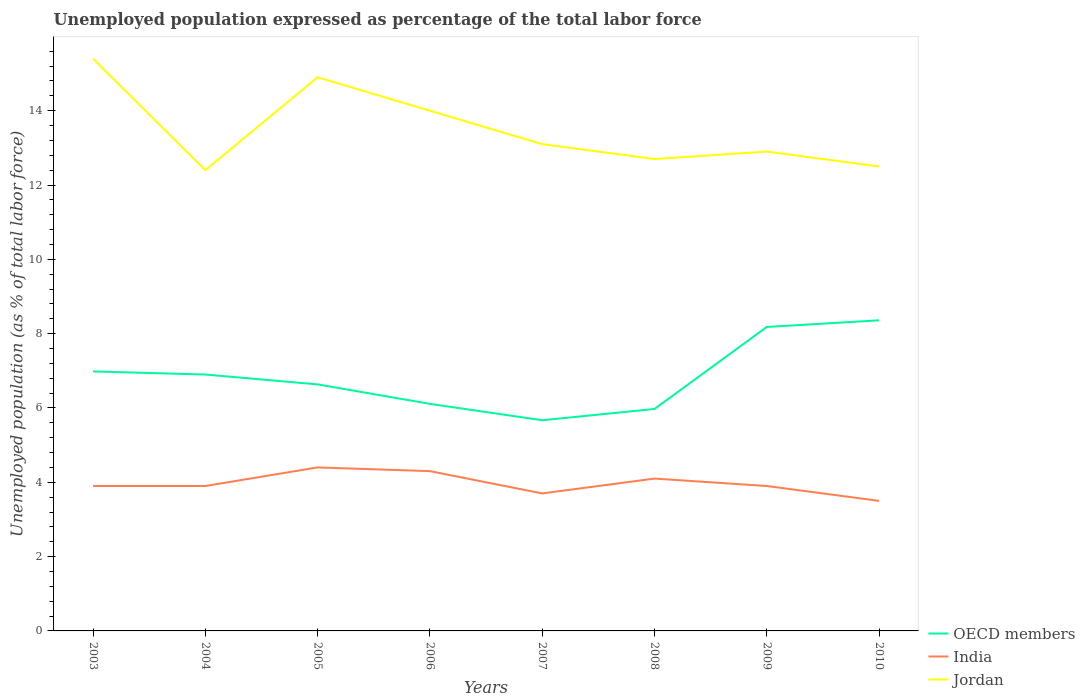How many different coloured lines are there?
Provide a short and direct response. 3. Across all years, what is the maximum unemployment in in OECD members?
Provide a succinct answer. 5.67. In which year was the unemployment in in India maximum?
Offer a terse response. 2010. What is the total unemployment in in Jordan in the graph?
Make the answer very short. 1.4. What is the difference between the highest and the second highest unemployment in in India?
Your response must be concise. 0.9. How many lines are there?
Your answer should be compact. 3. How many years are there in the graph?
Offer a very short reply. 8. Does the graph contain any zero values?
Give a very brief answer. No. Where does the legend appear in the graph?
Provide a succinct answer. Bottom right. How are the legend labels stacked?
Your answer should be compact. Vertical. What is the title of the graph?
Offer a terse response. Unemployed population expressed as percentage of the total labor force. What is the label or title of the X-axis?
Provide a short and direct response. Years. What is the label or title of the Y-axis?
Give a very brief answer. Unemployed population (as % of total labor force). What is the Unemployed population (as % of total labor force) of OECD members in 2003?
Keep it short and to the point. 6.98. What is the Unemployed population (as % of total labor force) of India in 2003?
Ensure brevity in your answer.  3.9. What is the Unemployed population (as % of total labor force) of Jordan in 2003?
Your answer should be compact. 15.4. What is the Unemployed population (as % of total labor force) of OECD members in 2004?
Provide a short and direct response. 6.9. What is the Unemployed population (as % of total labor force) of India in 2004?
Your response must be concise. 3.9. What is the Unemployed population (as % of total labor force) of Jordan in 2004?
Offer a very short reply. 12.4. What is the Unemployed population (as % of total labor force) of OECD members in 2005?
Keep it short and to the point. 6.63. What is the Unemployed population (as % of total labor force) in India in 2005?
Keep it short and to the point. 4.4. What is the Unemployed population (as % of total labor force) in Jordan in 2005?
Provide a succinct answer. 14.9. What is the Unemployed population (as % of total labor force) in OECD members in 2006?
Keep it short and to the point. 6.11. What is the Unemployed population (as % of total labor force) of India in 2006?
Keep it short and to the point. 4.3. What is the Unemployed population (as % of total labor force) of OECD members in 2007?
Offer a terse response. 5.67. What is the Unemployed population (as % of total labor force) in India in 2007?
Keep it short and to the point. 3.7. What is the Unemployed population (as % of total labor force) in Jordan in 2007?
Provide a short and direct response. 13.1. What is the Unemployed population (as % of total labor force) of OECD members in 2008?
Keep it short and to the point. 5.97. What is the Unemployed population (as % of total labor force) in India in 2008?
Ensure brevity in your answer.  4.1. What is the Unemployed population (as % of total labor force) of Jordan in 2008?
Make the answer very short. 12.7. What is the Unemployed population (as % of total labor force) in OECD members in 2009?
Offer a very short reply. 8.18. What is the Unemployed population (as % of total labor force) of India in 2009?
Your answer should be very brief. 3.9. What is the Unemployed population (as % of total labor force) in Jordan in 2009?
Your answer should be compact. 12.9. What is the Unemployed population (as % of total labor force) of OECD members in 2010?
Ensure brevity in your answer.  8.36. What is the Unemployed population (as % of total labor force) in Jordan in 2010?
Make the answer very short. 12.5. Across all years, what is the maximum Unemployed population (as % of total labor force) in OECD members?
Offer a terse response. 8.36. Across all years, what is the maximum Unemployed population (as % of total labor force) of India?
Provide a short and direct response. 4.4. Across all years, what is the maximum Unemployed population (as % of total labor force) in Jordan?
Keep it short and to the point. 15.4. Across all years, what is the minimum Unemployed population (as % of total labor force) in OECD members?
Offer a terse response. 5.67. Across all years, what is the minimum Unemployed population (as % of total labor force) in Jordan?
Keep it short and to the point. 12.4. What is the total Unemployed population (as % of total labor force) in OECD members in the graph?
Give a very brief answer. 54.81. What is the total Unemployed population (as % of total labor force) of India in the graph?
Ensure brevity in your answer.  31.7. What is the total Unemployed population (as % of total labor force) of Jordan in the graph?
Provide a short and direct response. 107.9. What is the difference between the Unemployed population (as % of total labor force) in OECD members in 2003 and that in 2004?
Your answer should be very brief. 0.08. What is the difference between the Unemployed population (as % of total labor force) in India in 2003 and that in 2004?
Your response must be concise. 0. What is the difference between the Unemployed population (as % of total labor force) of OECD members in 2003 and that in 2005?
Make the answer very short. 0.35. What is the difference between the Unemployed population (as % of total labor force) of India in 2003 and that in 2005?
Offer a very short reply. -0.5. What is the difference between the Unemployed population (as % of total labor force) of Jordan in 2003 and that in 2005?
Provide a short and direct response. 0.5. What is the difference between the Unemployed population (as % of total labor force) of OECD members in 2003 and that in 2006?
Keep it short and to the point. 0.87. What is the difference between the Unemployed population (as % of total labor force) of OECD members in 2003 and that in 2007?
Keep it short and to the point. 1.31. What is the difference between the Unemployed population (as % of total labor force) in India in 2003 and that in 2007?
Your answer should be very brief. 0.2. What is the difference between the Unemployed population (as % of total labor force) of Jordan in 2003 and that in 2007?
Make the answer very short. 2.3. What is the difference between the Unemployed population (as % of total labor force) in OECD members in 2003 and that in 2008?
Offer a terse response. 1.01. What is the difference between the Unemployed population (as % of total labor force) of India in 2003 and that in 2008?
Provide a succinct answer. -0.2. What is the difference between the Unemployed population (as % of total labor force) in OECD members in 2003 and that in 2009?
Make the answer very short. -1.2. What is the difference between the Unemployed population (as % of total labor force) of OECD members in 2003 and that in 2010?
Ensure brevity in your answer.  -1.38. What is the difference between the Unemployed population (as % of total labor force) of India in 2003 and that in 2010?
Provide a succinct answer. 0.4. What is the difference between the Unemployed population (as % of total labor force) in Jordan in 2003 and that in 2010?
Give a very brief answer. 2.9. What is the difference between the Unemployed population (as % of total labor force) of OECD members in 2004 and that in 2005?
Provide a succinct answer. 0.27. What is the difference between the Unemployed population (as % of total labor force) of Jordan in 2004 and that in 2005?
Provide a succinct answer. -2.5. What is the difference between the Unemployed population (as % of total labor force) of OECD members in 2004 and that in 2006?
Ensure brevity in your answer.  0.79. What is the difference between the Unemployed population (as % of total labor force) in India in 2004 and that in 2006?
Your answer should be very brief. -0.4. What is the difference between the Unemployed population (as % of total labor force) of OECD members in 2004 and that in 2007?
Ensure brevity in your answer.  1.23. What is the difference between the Unemployed population (as % of total labor force) of India in 2004 and that in 2007?
Provide a short and direct response. 0.2. What is the difference between the Unemployed population (as % of total labor force) in OECD members in 2004 and that in 2008?
Offer a terse response. 0.93. What is the difference between the Unemployed population (as % of total labor force) of OECD members in 2004 and that in 2009?
Keep it short and to the point. -1.28. What is the difference between the Unemployed population (as % of total labor force) of India in 2004 and that in 2009?
Ensure brevity in your answer.  0. What is the difference between the Unemployed population (as % of total labor force) of Jordan in 2004 and that in 2009?
Keep it short and to the point. -0.5. What is the difference between the Unemployed population (as % of total labor force) of OECD members in 2004 and that in 2010?
Your answer should be very brief. -1.46. What is the difference between the Unemployed population (as % of total labor force) in India in 2004 and that in 2010?
Your answer should be very brief. 0.4. What is the difference between the Unemployed population (as % of total labor force) in OECD members in 2005 and that in 2006?
Keep it short and to the point. 0.52. What is the difference between the Unemployed population (as % of total labor force) of India in 2005 and that in 2006?
Ensure brevity in your answer.  0.1. What is the difference between the Unemployed population (as % of total labor force) in OECD members in 2005 and that in 2007?
Provide a short and direct response. 0.96. What is the difference between the Unemployed population (as % of total labor force) of India in 2005 and that in 2007?
Ensure brevity in your answer.  0.7. What is the difference between the Unemployed population (as % of total labor force) in Jordan in 2005 and that in 2007?
Make the answer very short. 1.8. What is the difference between the Unemployed population (as % of total labor force) of OECD members in 2005 and that in 2008?
Your answer should be compact. 0.66. What is the difference between the Unemployed population (as % of total labor force) of Jordan in 2005 and that in 2008?
Provide a short and direct response. 2.2. What is the difference between the Unemployed population (as % of total labor force) in OECD members in 2005 and that in 2009?
Offer a very short reply. -1.55. What is the difference between the Unemployed population (as % of total labor force) in OECD members in 2005 and that in 2010?
Keep it short and to the point. -1.72. What is the difference between the Unemployed population (as % of total labor force) of Jordan in 2005 and that in 2010?
Provide a succinct answer. 2.4. What is the difference between the Unemployed population (as % of total labor force) of OECD members in 2006 and that in 2007?
Your answer should be compact. 0.44. What is the difference between the Unemployed population (as % of total labor force) in Jordan in 2006 and that in 2007?
Provide a short and direct response. 0.9. What is the difference between the Unemployed population (as % of total labor force) in OECD members in 2006 and that in 2008?
Your response must be concise. 0.14. What is the difference between the Unemployed population (as % of total labor force) in India in 2006 and that in 2008?
Provide a succinct answer. 0.2. What is the difference between the Unemployed population (as % of total labor force) of OECD members in 2006 and that in 2009?
Give a very brief answer. -2.07. What is the difference between the Unemployed population (as % of total labor force) in India in 2006 and that in 2009?
Offer a very short reply. 0.4. What is the difference between the Unemployed population (as % of total labor force) of Jordan in 2006 and that in 2009?
Offer a terse response. 1.1. What is the difference between the Unemployed population (as % of total labor force) of OECD members in 2006 and that in 2010?
Provide a short and direct response. -2.25. What is the difference between the Unemployed population (as % of total labor force) in India in 2006 and that in 2010?
Offer a terse response. 0.8. What is the difference between the Unemployed population (as % of total labor force) in Jordan in 2006 and that in 2010?
Your answer should be very brief. 1.5. What is the difference between the Unemployed population (as % of total labor force) of OECD members in 2007 and that in 2008?
Your answer should be compact. -0.3. What is the difference between the Unemployed population (as % of total labor force) of India in 2007 and that in 2008?
Offer a terse response. -0.4. What is the difference between the Unemployed population (as % of total labor force) in OECD members in 2007 and that in 2009?
Keep it short and to the point. -2.51. What is the difference between the Unemployed population (as % of total labor force) of India in 2007 and that in 2009?
Your answer should be very brief. -0.2. What is the difference between the Unemployed population (as % of total labor force) in OECD members in 2007 and that in 2010?
Provide a short and direct response. -2.69. What is the difference between the Unemployed population (as % of total labor force) in India in 2007 and that in 2010?
Your response must be concise. 0.2. What is the difference between the Unemployed population (as % of total labor force) of Jordan in 2007 and that in 2010?
Your answer should be compact. 0.6. What is the difference between the Unemployed population (as % of total labor force) in OECD members in 2008 and that in 2009?
Provide a succinct answer. -2.21. What is the difference between the Unemployed population (as % of total labor force) of India in 2008 and that in 2009?
Give a very brief answer. 0.2. What is the difference between the Unemployed population (as % of total labor force) in Jordan in 2008 and that in 2009?
Your response must be concise. -0.2. What is the difference between the Unemployed population (as % of total labor force) in OECD members in 2008 and that in 2010?
Keep it short and to the point. -2.39. What is the difference between the Unemployed population (as % of total labor force) of India in 2008 and that in 2010?
Make the answer very short. 0.6. What is the difference between the Unemployed population (as % of total labor force) in OECD members in 2009 and that in 2010?
Provide a short and direct response. -0.18. What is the difference between the Unemployed population (as % of total labor force) of India in 2009 and that in 2010?
Make the answer very short. 0.4. What is the difference between the Unemployed population (as % of total labor force) in Jordan in 2009 and that in 2010?
Make the answer very short. 0.4. What is the difference between the Unemployed population (as % of total labor force) in OECD members in 2003 and the Unemployed population (as % of total labor force) in India in 2004?
Your answer should be very brief. 3.08. What is the difference between the Unemployed population (as % of total labor force) in OECD members in 2003 and the Unemployed population (as % of total labor force) in Jordan in 2004?
Provide a short and direct response. -5.42. What is the difference between the Unemployed population (as % of total labor force) in OECD members in 2003 and the Unemployed population (as % of total labor force) in India in 2005?
Keep it short and to the point. 2.58. What is the difference between the Unemployed population (as % of total labor force) in OECD members in 2003 and the Unemployed population (as % of total labor force) in Jordan in 2005?
Your answer should be very brief. -7.92. What is the difference between the Unemployed population (as % of total labor force) in OECD members in 2003 and the Unemployed population (as % of total labor force) in India in 2006?
Make the answer very short. 2.68. What is the difference between the Unemployed population (as % of total labor force) in OECD members in 2003 and the Unemployed population (as % of total labor force) in Jordan in 2006?
Make the answer very short. -7.02. What is the difference between the Unemployed population (as % of total labor force) in India in 2003 and the Unemployed population (as % of total labor force) in Jordan in 2006?
Offer a very short reply. -10.1. What is the difference between the Unemployed population (as % of total labor force) of OECD members in 2003 and the Unemployed population (as % of total labor force) of India in 2007?
Your answer should be compact. 3.28. What is the difference between the Unemployed population (as % of total labor force) in OECD members in 2003 and the Unemployed population (as % of total labor force) in Jordan in 2007?
Ensure brevity in your answer.  -6.12. What is the difference between the Unemployed population (as % of total labor force) of India in 2003 and the Unemployed population (as % of total labor force) of Jordan in 2007?
Keep it short and to the point. -9.2. What is the difference between the Unemployed population (as % of total labor force) of OECD members in 2003 and the Unemployed population (as % of total labor force) of India in 2008?
Make the answer very short. 2.88. What is the difference between the Unemployed population (as % of total labor force) of OECD members in 2003 and the Unemployed population (as % of total labor force) of Jordan in 2008?
Provide a short and direct response. -5.72. What is the difference between the Unemployed population (as % of total labor force) in India in 2003 and the Unemployed population (as % of total labor force) in Jordan in 2008?
Your answer should be compact. -8.8. What is the difference between the Unemployed population (as % of total labor force) in OECD members in 2003 and the Unemployed population (as % of total labor force) in India in 2009?
Ensure brevity in your answer.  3.08. What is the difference between the Unemployed population (as % of total labor force) of OECD members in 2003 and the Unemployed population (as % of total labor force) of Jordan in 2009?
Keep it short and to the point. -5.92. What is the difference between the Unemployed population (as % of total labor force) of India in 2003 and the Unemployed population (as % of total labor force) of Jordan in 2009?
Give a very brief answer. -9. What is the difference between the Unemployed population (as % of total labor force) of OECD members in 2003 and the Unemployed population (as % of total labor force) of India in 2010?
Your answer should be compact. 3.48. What is the difference between the Unemployed population (as % of total labor force) of OECD members in 2003 and the Unemployed population (as % of total labor force) of Jordan in 2010?
Make the answer very short. -5.52. What is the difference between the Unemployed population (as % of total labor force) in OECD members in 2004 and the Unemployed population (as % of total labor force) in India in 2005?
Offer a very short reply. 2.5. What is the difference between the Unemployed population (as % of total labor force) in OECD members in 2004 and the Unemployed population (as % of total labor force) in Jordan in 2005?
Give a very brief answer. -8. What is the difference between the Unemployed population (as % of total labor force) of OECD members in 2004 and the Unemployed population (as % of total labor force) of India in 2006?
Ensure brevity in your answer.  2.6. What is the difference between the Unemployed population (as % of total labor force) of OECD members in 2004 and the Unemployed population (as % of total labor force) of Jordan in 2006?
Provide a succinct answer. -7.1. What is the difference between the Unemployed population (as % of total labor force) of India in 2004 and the Unemployed population (as % of total labor force) of Jordan in 2006?
Give a very brief answer. -10.1. What is the difference between the Unemployed population (as % of total labor force) in OECD members in 2004 and the Unemployed population (as % of total labor force) in India in 2007?
Offer a very short reply. 3.2. What is the difference between the Unemployed population (as % of total labor force) of OECD members in 2004 and the Unemployed population (as % of total labor force) of Jordan in 2007?
Offer a terse response. -6.2. What is the difference between the Unemployed population (as % of total labor force) of OECD members in 2004 and the Unemployed population (as % of total labor force) of India in 2008?
Provide a short and direct response. 2.8. What is the difference between the Unemployed population (as % of total labor force) of OECD members in 2004 and the Unemployed population (as % of total labor force) of Jordan in 2008?
Provide a short and direct response. -5.8. What is the difference between the Unemployed population (as % of total labor force) of OECD members in 2004 and the Unemployed population (as % of total labor force) of India in 2009?
Offer a very short reply. 3. What is the difference between the Unemployed population (as % of total labor force) in OECD members in 2004 and the Unemployed population (as % of total labor force) in Jordan in 2009?
Provide a succinct answer. -6. What is the difference between the Unemployed population (as % of total labor force) in OECD members in 2004 and the Unemployed population (as % of total labor force) in India in 2010?
Make the answer very short. 3.4. What is the difference between the Unemployed population (as % of total labor force) of OECD members in 2004 and the Unemployed population (as % of total labor force) of Jordan in 2010?
Offer a terse response. -5.6. What is the difference between the Unemployed population (as % of total labor force) in India in 2004 and the Unemployed population (as % of total labor force) in Jordan in 2010?
Give a very brief answer. -8.6. What is the difference between the Unemployed population (as % of total labor force) of OECD members in 2005 and the Unemployed population (as % of total labor force) of India in 2006?
Your answer should be compact. 2.33. What is the difference between the Unemployed population (as % of total labor force) in OECD members in 2005 and the Unemployed population (as % of total labor force) in Jordan in 2006?
Give a very brief answer. -7.37. What is the difference between the Unemployed population (as % of total labor force) in OECD members in 2005 and the Unemployed population (as % of total labor force) in India in 2007?
Keep it short and to the point. 2.93. What is the difference between the Unemployed population (as % of total labor force) in OECD members in 2005 and the Unemployed population (as % of total labor force) in Jordan in 2007?
Your answer should be very brief. -6.47. What is the difference between the Unemployed population (as % of total labor force) in OECD members in 2005 and the Unemployed population (as % of total labor force) in India in 2008?
Your answer should be very brief. 2.53. What is the difference between the Unemployed population (as % of total labor force) in OECD members in 2005 and the Unemployed population (as % of total labor force) in Jordan in 2008?
Ensure brevity in your answer.  -6.07. What is the difference between the Unemployed population (as % of total labor force) in India in 2005 and the Unemployed population (as % of total labor force) in Jordan in 2008?
Provide a short and direct response. -8.3. What is the difference between the Unemployed population (as % of total labor force) of OECD members in 2005 and the Unemployed population (as % of total labor force) of India in 2009?
Give a very brief answer. 2.73. What is the difference between the Unemployed population (as % of total labor force) in OECD members in 2005 and the Unemployed population (as % of total labor force) in Jordan in 2009?
Offer a very short reply. -6.27. What is the difference between the Unemployed population (as % of total labor force) in OECD members in 2005 and the Unemployed population (as % of total labor force) in India in 2010?
Your answer should be very brief. 3.13. What is the difference between the Unemployed population (as % of total labor force) of OECD members in 2005 and the Unemployed population (as % of total labor force) of Jordan in 2010?
Keep it short and to the point. -5.87. What is the difference between the Unemployed population (as % of total labor force) in India in 2005 and the Unemployed population (as % of total labor force) in Jordan in 2010?
Your answer should be very brief. -8.1. What is the difference between the Unemployed population (as % of total labor force) of OECD members in 2006 and the Unemployed population (as % of total labor force) of India in 2007?
Offer a terse response. 2.41. What is the difference between the Unemployed population (as % of total labor force) in OECD members in 2006 and the Unemployed population (as % of total labor force) in Jordan in 2007?
Your answer should be very brief. -6.99. What is the difference between the Unemployed population (as % of total labor force) in India in 2006 and the Unemployed population (as % of total labor force) in Jordan in 2007?
Keep it short and to the point. -8.8. What is the difference between the Unemployed population (as % of total labor force) of OECD members in 2006 and the Unemployed population (as % of total labor force) of India in 2008?
Your answer should be very brief. 2.01. What is the difference between the Unemployed population (as % of total labor force) of OECD members in 2006 and the Unemployed population (as % of total labor force) of Jordan in 2008?
Keep it short and to the point. -6.59. What is the difference between the Unemployed population (as % of total labor force) of OECD members in 2006 and the Unemployed population (as % of total labor force) of India in 2009?
Offer a very short reply. 2.21. What is the difference between the Unemployed population (as % of total labor force) of OECD members in 2006 and the Unemployed population (as % of total labor force) of Jordan in 2009?
Offer a terse response. -6.79. What is the difference between the Unemployed population (as % of total labor force) in India in 2006 and the Unemployed population (as % of total labor force) in Jordan in 2009?
Ensure brevity in your answer.  -8.6. What is the difference between the Unemployed population (as % of total labor force) in OECD members in 2006 and the Unemployed population (as % of total labor force) in India in 2010?
Ensure brevity in your answer.  2.61. What is the difference between the Unemployed population (as % of total labor force) in OECD members in 2006 and the Unemployed population (as % of total labor force) in Jordan in 2010?
Keep it short and to the point. -6.39. What is the difference between the Unemployed population (as % of total labor force) in India in 2006 and the Unemployed population (as % of total labor force) in Jordan in 2010?
Your answer should be compact. -8.2. What is the difference between the Unemployed population (as % of total labor force) of OECD members in 2007 and the Unemployed population (as % of total labor force) of India in 2008?
Your answer should be very brief. 1.57. What is the difference between the Unemployed population (as % of total labor force) of OECD members in 2007 and the Unemployed population (as % of total labor force) of Jordan in 2008?
Ensure brevity in your answer.  -7.03. What is the difference between the Unemployed population (as % of total labor force) of India in 2007 and the Unemployed population (as % of total labor force) of Jordan in 2008?
Ensure brevity in your answer.  -9. What is the difference between the Unemployed population (as % of total labor force) in OECD members in 2007 and the Unemployed population (as % of total labor force) in India in 2009?
Give a very brief answer. 1.77. What is the difference between the Unemployed population (as % of total labor force) in OECD members in 2007 and the Unemployed population (as % of total labor force) in Jordan in 2009?
Keep it short and to the point. -7.23. What is the difference between the Unemployed population (as % of total labor force) in OECD members in 2007 and the Unemployed population (as % of total labor force) in India in 2010?
Provide a succinct answer. 2.17. What is the difference between the Unemployed population (as % of total labor force) of OECD members in 2007 and the Unemployed population (as % of total labor force) of Jordan in 2010?
Offer a very short reply. -6.83. What is the difference between the Unemployed population (as % of total labor force) of OECD members in 2008 and the Unemployed population (as % of total labor force) of India in 2009?
Give a very brief answer. 2.07. What is the difference between the Unemployed population (as % of total labor force) in OECD members in 2008 and the Unemployed population (as % of total labor force) in Jordan in 2009?
Give a very brief answer. -6.93. What is the difference between the Unemployed population (as % of total labor force) of OECD members in 2008 and the Unemployed population (as % of total labor force) of India in 2010?
Make the answer very short. 2.47. What is the difference between the Unemployed population (as % of total labor force) of OECD members in 2008 and the Unemployed population (as % of total labor force) of Jordan in 2010?
Your answer should be compact. -6.53. What is the difference between the Unemployed population (as % of total labor force) of India in 2008 and the Unemployed population (as % of total labor force) of Jordan in 2010?
Your answer should be very brief. -8.4. What is the difference between the Unemployed population (as % of total labor force) of OECD members in 2009 and the Unemployed population (as % of total labor force) of India in 2010?
Your response must be concise. 4.68. What is the difference between the Unemployed population (as % of total labor force) in OECD members in 2009 and the Unemployed population (as % of total labor force) in Jordan in 2010?
Your answer should be compact. -4.32. What is the average Unemployed population (as % of total labor force) of OECD members per year?
Make the answer very short. 6.85. What is the average Unemployed population (as % of total labor force) in India per year?
Your answer should be very brief. 3.96. What is the average Unemployed population (as % of total labor force) in Jordan per year?
Make the answer very short. 13.49. In the year 2003, what is the difference between the Unemployed population (as % of total labor force) in OECD members and Unemployed population (as % of total labor force) in India?
Keep it short and to the point. 3.08. In the year 2003, what is the difference between the Unemployed population (as % of total labor force) of OECD members and Unemployed population (as % of total labor force) of Jordan?
Provide a short and direct response. -8.42. In the year 2004, what is the difference between the Unemployed population (as % of total labor force) in OECD members and Unemployed population (as % of total labor force) in India?
Provide a succinct answer. 3. In the year 2004, what is the difference between the Unemployed population (as % of total labor force) of OECD members and Unemployed population (as % of total labor force) of Jordan?
Offer a terse response. -5.5. In the year 2005, what is the difference between the Unemployed population (as % of total labor force) of OECD members and Unemployed population (as % of total labor force) of India?
Your answer should be very brief. 2.23. In the year 2005, what is the difference between the Unemployed population (as % of total labor force) of OECD members and Unemployed population (as % of total labor force) of Jordan?
Make the answer very short. -8.27. In the year 2006, what is the difference between the Unemployed population (as % of total labor force) of OECD members and Unemployed population (as % of total labor force) of India?
Keep it short and to the point. 1.81. In the year 2006, what is the difference between the Unemployed population (as % of total labor force) in OECD members and Unemployed population (as % of total labor force) in Jordan?
Your answer should be very brief. -7.89. In the year 2007, what is the difference between the Unemployed population (as % of total labor force) of OECD members and Unemployed population (as % of total labor force) of India?
Your response must be concise. 1.97. In the year 2007, what is the difference between the Unemployed population (as % of total labor force) in OECD members and Unemployed population (as % of total labor force) in Jordan?
Your answer should be very brief. -7.43. In the year 2007, what is the difference between the Unemployed population (as % of total labor force) in India and Unemployed population (as % of total labor force) in Jordan?
Ensure brevity in your answer.  -9.4. In the year 2008, what is the difference between the Unemployed population (as % of total labor force) of OECD members and Unemployed population (as % of total labor force) of India?
Provide a short and direct response. 1.87. In the year 2008, what is the difference between the Unemployed population (as % of total labor force) of OECD members and Unemployed population (as % of total labor force) of Jordan?
Give a very brief answer. -6.73. In the year 2008, what is the difference between the Unemployed population (as % of total labor force) of India and Unemployed population (as % of total labor force) of Jordan?
Provide a short and direct response. -8.6. In the year 2009, what is the difference between the Unemployed population (as % of total labor force) in OECD members and Unemployed population (as % of total labor force) in India?
Offer a very short reply. 4.28. In the year 2009, what is the difference between the Unemployed population (as % of total labor force) in OECD members and Unemployed population (as % of total labor force) in Jordan?
Your answer should be very brief. -4.72. In the year 2009, what is the difference between the Unemployed population (as % of total labor force) of India and Unemployed population (as % of total labor force) of Jordan?
Ensure brevity in your answer.  -9. In the year 2010, what is the difference between the Unemployed population (as % of total labor force) in OECD members and Unemployed population (as % of total labor force) in India?
Provide a succinct answer. 4.86. In the year 2010, what is the difference between the Unemployed population (as % of total labor force) in OECD members and Unemployed population (as % of total labor force) in Jordan?
Keep it short and to the point. -4.14. In the year 2010, what is the difference between the Unemployed population (as % of total labor force) of India and Unemployed population (as % of total labor force) of Jordan?
Make the answer very short. -9. What is the ratio of the Unemployed population (as % of total labor force) in OECD members in 2003 to that in 2004?
Give a very brief answer. 1.01. What is the ratio of the Unemployed population (as % of total labor force) of India in 2003 to that in 2004?
Offer a very short reply. 1. What is the ratio of the Unemployed population (as % of total labor force) in Jordan in 2003 to that in 2004?
Ensure brevity in your answer.  1.24. What is the ratio of the Unemployed population (as % of total labor force) of OECD members in 2003 to that in 2005?
Keep it short and to the point. 1.05. What is the ratio of the Unemployed population (as % of total labor force) in India in 2003 to that in 2005?
Ensure brevity in your answer.  0.89. What is the ratio of the Unemployed population (as % of total labor force) in Jordan in 2003 to that in 2005?
Your answer should be very brief. 1.03. What is the ratio of the Unemployed population (as % of total labor force) in OECD members in 2003 to that in 2006?
Provide a succinct answer. 1.14. What is the ratio of the Unemployed population (as % of total labor force) of India in 2003 to that in 2006?
Your answer should be compact. 0.91. What is the ratio of the Unemployed population (as % of total labor force) of OECD members in 2003 to that in 2007?
Keep it short and to the point. 1.23. What is the ratio of the Unemployed population (as % of total labor force) in India in 2003 to that in 2007?
Your answer should be compact. 1.05. What is the ratio of the Unemployed population (as % of total labor force) in Jordan in 2003 to that in 2007?
Ensure brevity in your answer.  1.18. What is the ratio of the Unemployed population (as % of total labor force) of OECD members in 2003 to that in 2008?
Your answer should be very brief. 1.17. What is the ratio of the Unemployed population (as % of total labor force) of India in 2003 to that in 2008?
Your answer should be compact. 0.95. What is the ratio of the Unemployed population (as % of total labor force) in Jordan in 2003 to that in 2008?
Your response must be concise. 1.21. What is the ratio of the Unemployed population (as % of total labor force) in OECD members in 2003 to that in 2009?
Make the answer very short. 0.85. What is the ratio of the Unemployed population (as % of total labor force) of Jordan in 2003 to that in 2009?
Offer a very short reply. 1.19. What is the ratio of the Unemployed population (as % of total labor force) of OECD members in 2003 to that in 2010?
Give a very brief answer. 0.84. What is the ratio of the Unemployed population (as % of total labor force) of India in 2003 to that in 2010?
Give a very brief answer. 1.11. What is the ratio of the Unemployed population (as % of total labor force) in Jordan in 2003 to that in 2010?
Keep it short and to the point. 1.23. What is the ratio of the Unemployed population (as % of total labor force) in India in 2004 to that in 2005?
Keep it short and to the point. 0.89. What is the ratio of the Unemployed population (as % of total labor force) in Jordan in 2004 to that in 2005?
Provide a succinct answer. 0.83. What is the ratio of the Unemployed population (as % of total labor force) of OECD members in 2004 to that in 2006?
Provide a short and direct response. 1.13. What is the ratio of the Unemployed population (as % of total labor force) of India in 2004 to that in 2006?
Provide a succinct answer. 0.91. What is the ratio of the Unemployed population (as % of total labor force) in Jordan in 2004 to that in 2006?
Make the answer very short. 0.89. What is the ratio of the Unemployed population (as % of total labor force) of OECD members in 2004 to that in 2007?
Your answer should be very brief. 1.22. What is the ratio of the Unemployed population (as % of total labor force) in India in 2004 to that in 2007?
Your response must be concise. 1.05. What is the ratio of the Unemployed population (as % of total labor force) in Jordan in 2004 to that in 2007?
Provide a short and direct response. 0.95. What is the ratio of the Unemployed population (as % of total labor force) of OECD members in 2004 to that in 2008?
Keep it short and to the point. 1.16. What is the ratio of the Unemployed population (as % of total labor force) in India in 2004 to that in 2008?
Make the answer very short. 0.95. What is the ratio of the Unemployed population (as % of total labor force) of Jordan in 2004 to that in 2008?
Make the answer very short. 0.98. What is the ratio of the Unemployed population (as % of total labor force) of OECD members in 2004 to that in 2009?
Offer a terse response. 0.84. What is the ratio of the Unemployed population (as % of total labor force) in India in 2004 to that in 2009?
Your answer should be very brief. 1. What is the ratio of the Unemployed population (as % of total labor force) in Jordan in 2004 to that in 2009?
Offer a terse response. 0.96. What is the ratio of the Unemployed population (as % of total labor force) of OECD members in 2004 to that in 2010?
Your answer should be very brief. 0.83. What is the ratio of the Unemployed population (as % of total labor force) of India in 2004 to that in 2010?
Provide a short and direct response. 1.11. What is the ratio of the Unemployed population (as % of total labor force) of Jordan in 2004 to that in 2010?
Provide a succinct answer. 0.99. What is the ratio of the Unemployed population (as % of total labor force) of OECD members in 2005 to that in 2006?
Provide a short and direct response. 1.09. What is the ratio of the Unemployed population (as % of total labor force) in India in 2005 to that in 2006?
Your response must be concise. 1.02. What is the ratio of the Unemployed population (as % of total labor force) of Jordan in 2005 to that in 2006?
Provide a succinct answer. 1.06. What is the ratio of the Unemployed population (as % of total labor force) in OECD members in 2005 to that in 2007?
Ensure brevity in your answer.  1.17. What is the ratio of the Unemployed population (as % of total labor force) in India in 2005 to that in 2007?
Your answer should be very brief. 1.19. What is the ratio of the Unemployed population (as % of total labor force) in Jordan in 2005 to that in 2007?
Your answer should be very brief. 1.14. What is the ratio of the Unemployed population (as % of total labor force) of OECD members in 2005 to that in 2008?
Your answer should be compact. 1.11. What is the ratio of the Unemployed population (as % of total labor force) in India in 2005 to that in 2008?
Your response must be concise. 1.07. What is the ratio of the Unemployed population (as % of total labor force) in Jordan in 2005 to that in 2008?
Make the answer very short. 1.17. What is the ratio of the Unemployed population (as % of total labor force) in OECD members in 2005 to that in 2009?
Provide a short and direct response. 0.81. What is the ratio of the Unemployed population (as % of total labor force) of India in 2005 to that in 2009?
Your answer should be very brief. 1.13. What is the ratio of the Unemployed population (as % of total labor force) of Jordan in 2005 to that in 2009?
Provide a short and direct response. 1.16. What is the ratio of the Unemployed population (as % of total labor force) in OECD members in 2005 to that in 2010?
Offer a terse response. 0.79. What is the ratio of the Unemployed population (as % of total labor force) of India in 2005 to that in 2010?
Give a very brief answer. 1.26. What is the ratio of the Unemployed population (as % of total labor force) of Jordan in 2005 to that in 2010?
Keep it short and to the point. 1.19. What is the ratio of the Unemployed population (as % of total labor force) of OECD members in 2006 to that in 2007?
Offer a very short reply. 1.08. What is the ratio of the Unemployed population (as % of total labor force) of India in 2006 to that in 2007?
Offer a very short reply. 1.16. What is the ratio of the Unemployed population (as % of total labor force) of Jordan in 2006 to that in 2007?
Your answer should be very brief. 1.07. What is the ratio of the Unemployed population (as % of total labor force) of OECD members in 2006 to that in 2008?
Your response must be concise. 1.02. What is the ratio of the Unemployed population (as % of total labor force) in India in 2006 to that in 2008?
Your response must be concise. 1.05. What is the ratio of the Unemployed population (as % of total labor force) of Jordan in 2006 to that in 2008?
Provide a short and direct response. 1.1. What is the ratio of the Unemployed population (as % of total labor force) in OECD members in 2006 to that in 2009?
Your answer should be very brief. 0.75. What is the ratio of the Unemployed population (as % of total labor force) in India in 2006 to that in 2009?
Offer a very short reply. 1.1. What is the ratio of the Unemployed population (as % of total labor force) in Jordan in 2006 to that in 2009?
Ensure brevity in your answer.  1.09. What is the ratio of the Unemployed population (as % of total labor force) in OECD members in 2006 to that in 2010?
Provide a short and direct response. 0.73. What is the ratio of the Unemployed population (as % of total labor force) in India in 2006 to that in 2010?
Give a very brief answer. 1.23. What is the ratio of the Unemployed population (as % of total labor force) of Jordan in 2006 to that in 2010?
Ensure brevity in your answer.  1.12. What is the ratio of the Unemployed population (as % of total labor force) in OECD members in 2007 to that in 2008?
Ensure brevity in your answer.  0.95. What is the ratio of the Unemployed population (as % of total labor force) of India in 2007 to that in 2008?
Offer a very short reply. 0.9. What is the ratio of the Unemployed population (as % of total labor force) in Jordan in 2007 to that in 2008?
Make the answer very short. 1.03. What is the ratio of the Unemployed population (as % of total labor force) in OECD members in 2007 to that in 2009?
Provide a succinct answer. 0.69. What is the ratio of the Unemployed population (as % of total labor force) of India in 2007 to that in 2009?
Your response must be concise. 0.95. What is the ratio of the Unemployed population (as % of total labor force) in Jordan in 2007 to that in 2009?
Provide a short and direct response. 1.02. What is the ratio of the Unemployed population (as % of total labor force) in OECD members in 2007 to that in 2010?
Make the answer very short. 0.68. What is the ratio of the Unemployed population (as % of total labor force) of India in 2007 to that in 2010?
Make the answer very short. 1.06. What is the ratio of the Unemployed population (as % of total labor force) of Jordan in 2007 to that in 2010?
Offer a terse response. 1.05. What is the ratio of the Unemployed population (as % of total labor force) of OECD members in 2008 to that in 2009?
Provide a succinct answer. 0.73. What is the ratio of the Unemployed population (as % of total labor force) of India in 2008 to that in 2009?
Your response must be concise. 1.05. What is the ratio of the Unemployed population (as % of total labor force) in Jordan in 2008 to that in 2009?
Your response must be concise. 0.98. What is the ratio of the Unemployed population (as % of total labor force) in OECD members in 2008 to that in 2010?
Your answer should be very brief. 0.71. What is the ratio of the Unemployed population (as % of total labor force) of India in 2008 to that in 2010?
Your answer should be very brief. 1.17. What is the ratio of the Unemployed population (as % of total labor force) of OECD members in 2009 to that in 2010?
Provide a succinct answer. 0.98. What is the ratio of the Unemployed population (as % of total labor force) of India in 2009 to that in 2010?
Give a very brief answer. 1.11. What is the ratio of the Unemployed population (as % of total labor force) of Jordan in 2009 to that in 2010?
Make the answer very short. 1.03. What is the difference between the highest and the second highest Unemployed population (as % of total labor force) in OECD members?
Give a very brief answer. 0.18. What is the difference between the highest and the second highest Unemployed population (as % of total labor force) in India?
Your answer should be very brief. 0.1. What is the difference between the highest and the lowest Unemployed population (as % of total labor force) in OECD members?
Offer a terse response. 2.69. 